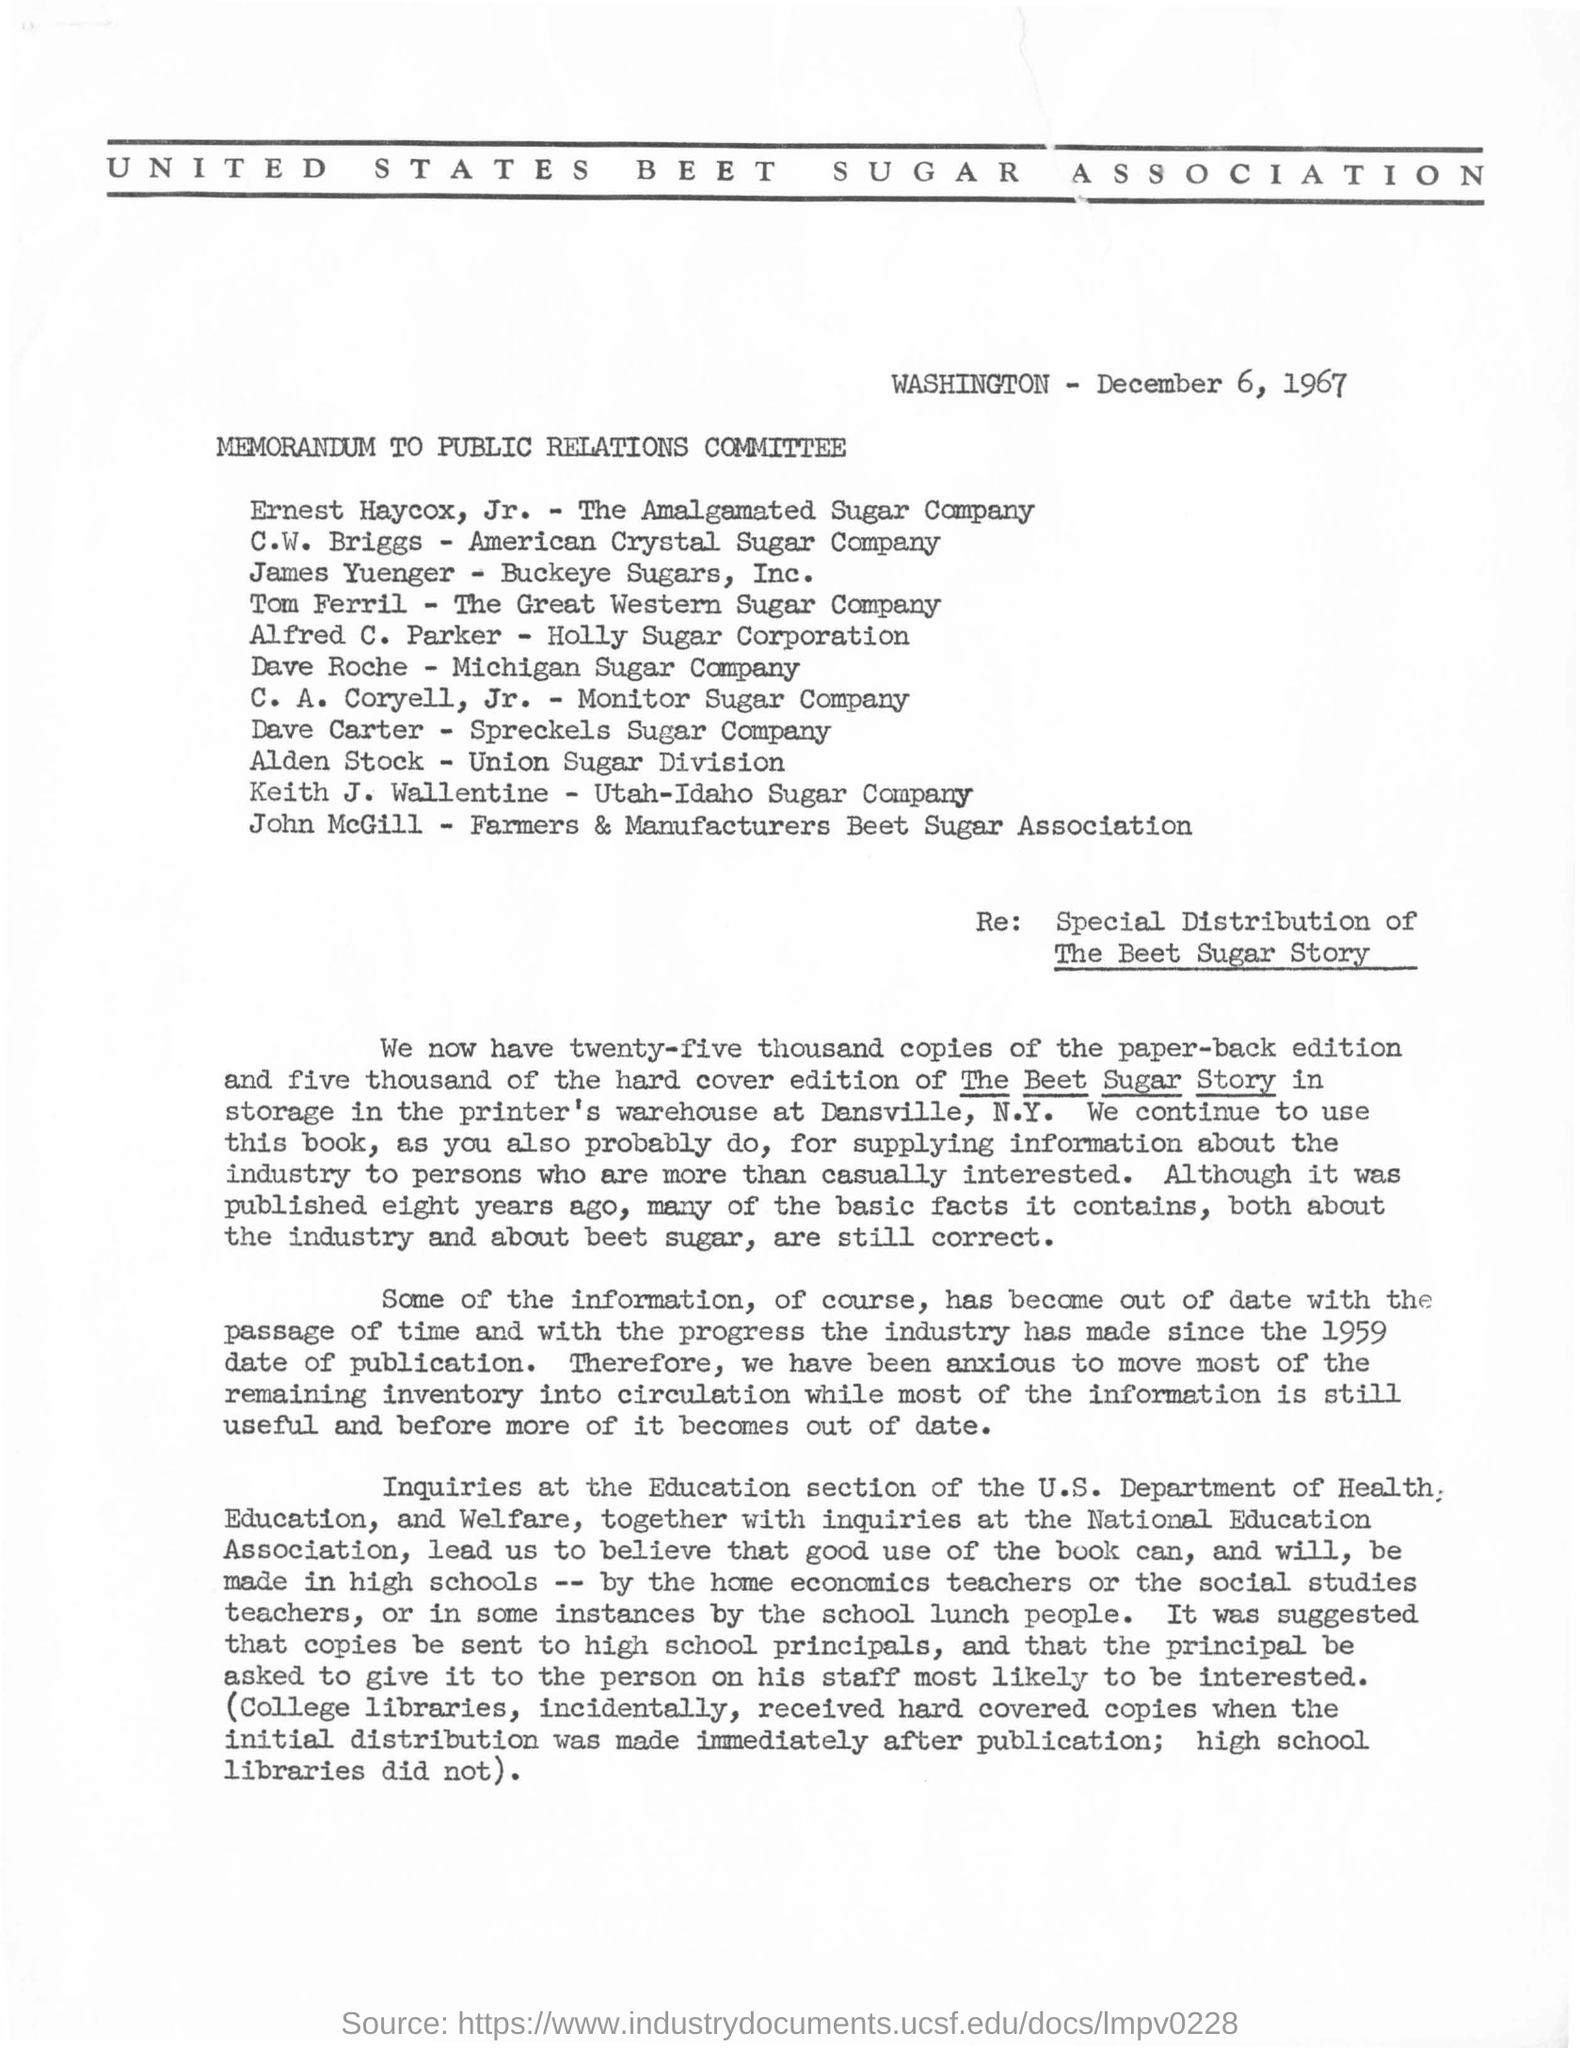What is the name of the association mentioned ?
Provide a succinct answer. United states beet sugar association. What is the date mentioned in the given page ?
Your answer should be very brief. December 6, 1967. To which company ernest haycox belongs to?
Provide a short and direct response. The amalgamated sugar company. To which company c.w. briggs belongs to ?
Provide a short and direct response. American crystal sugar company. To which company tom ferril belongs to ?
Offer a very short reply. The great western sugar company. To which company dave roche belongs to ?
Your response must be concise. Michigan sugar company. 